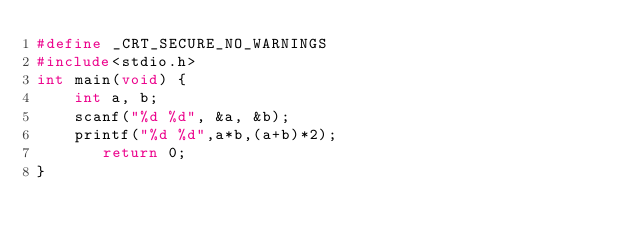<code> <loc_0><loc_0><loc_500><loc_500><_C_>#define _CRT_SECURE_NO_WARNINGS
#include<stdio.h>
int main(void) {
	int a, b;
	scanf("%d %d", &a, &b);
	printf("%d %d",a*b,(a+b)*2);
	   return 0;
}
</code> 